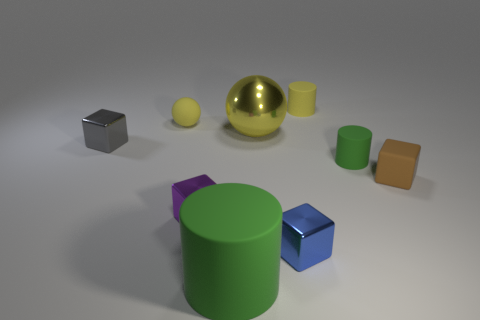What does the arrangement of objects tell you about the purpose of this image? The arrangement of objects seems to be deliberately placed for a composition exercise or a rendering test, commonly used in 3D modeling to showcase the capabilities of a rendering engine. Objects with different colors and surface properties are set against a neutral background to highlight their contrast and the effects of light on various materials. 